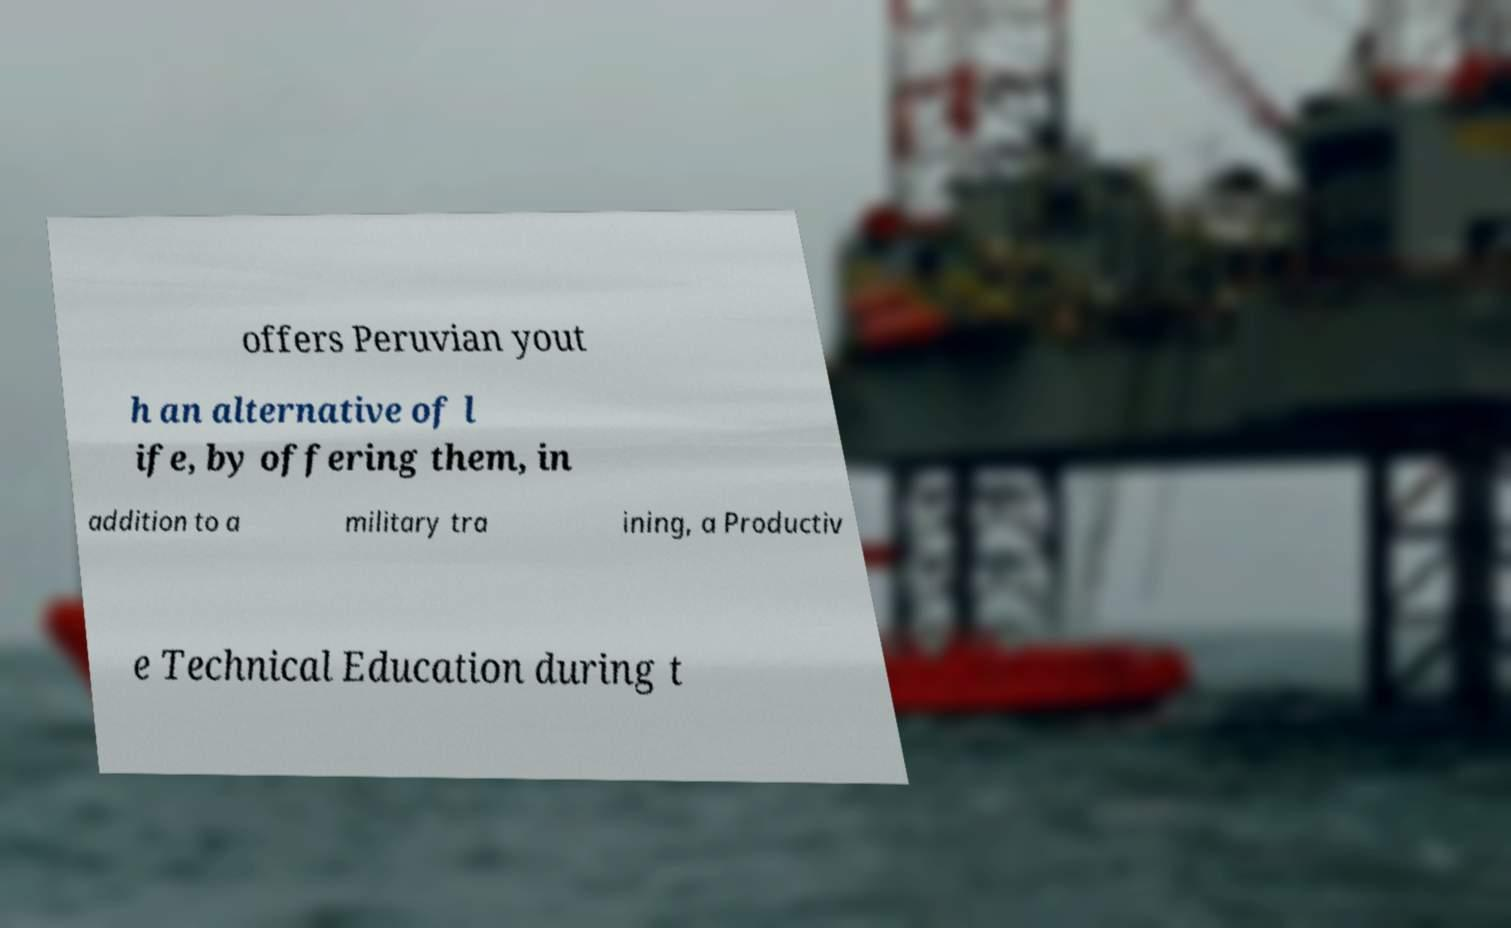There's text embedded in this image that I need extracted. Can you transcribe it verbatim? offers Peruvian yout h an alternative of l ife, by offering them, in addition to a military tra ining, a Productiv e Technical Education during t 